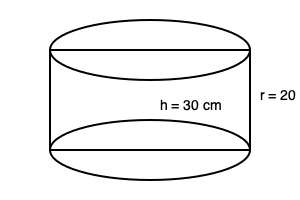Your CFO has purchased a new cylindrical fishing cooler for the upcoming company retreat. The cooler has a height of 30 cm and a radius of 20 cm. What is the volume of the cooler in liters? (Assume $\pi \approx 3.14$) To calculate the volume of a cylindrical fishing cooler, we'll use the formula for the volume of a cylinder:

$$V = \pi r^2 h$$

Where:
$V$ = volume
$r$ = radius of the base
$h$ = height of the cylinder

Given:
$r = 20$ cm
$h = 30$ cm
$\pi \approx 3.14$

Step 1: Substitute the values into the formula:
$$V = 3.14 \times 20^2 \times 30$$

Step 2: Calculate $20^2$:
$$V = 3.14 \times 400 \times 30$$

Step 3: Multiply all numbers:
$$V = 37,680 \text{ cm}^3$$

Step 4: Convert cubic centimeters to liters (1 liter = 1000 cm³):
$$V = 37,680 \div 1000 = 37.68 \text{ liters}$$

Therefore, the volume of the cylindrical fishing cooler is approximately 37.68 liters.
Answer: 37.68 liters 